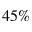<formula> <loc_0><loc_0><loc_500><loc_500>4 5 \%</formula> 